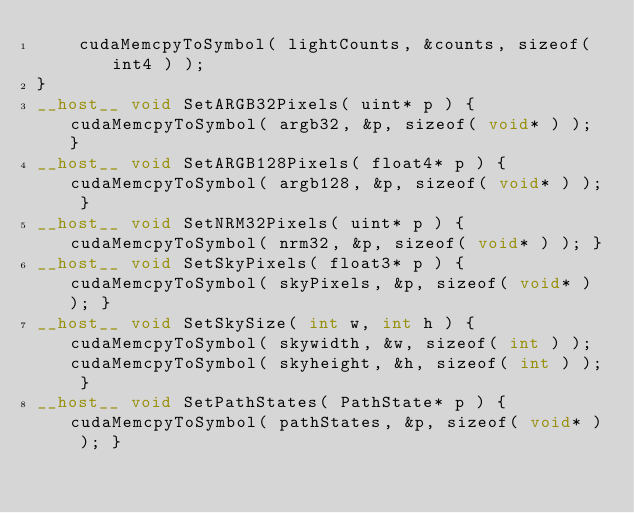Convert code to text. <code><loc_0><loc_0><loc_500><loc_500><_Cuda_>	cudaMemcpyToSymbol( lightCounts, &counts, sizeof( int4 ) );
}
__host__ void SetARGB32Pixels( uint* p ) { cudaMemcpyToSymbol( argb32, &p, sizeof( void* ) ); }
__host__ void SetARGB128Pixels( float4* p ) { cudaMemcpyToSymbol( argb128, &p, sizeof( void* ) ); }
__host__ void SetNRM32Pixels( uint* p ) { cudaMemcpyToSymbol( nrm32, &p, sizeof( void* ) ); }
__host__ void SetSkyPixels( float3* p ) { cudaMemcpyToSymbol( skyPixels, &p, sizeof( void* ) ); }
__host__ void SetSkySize( int w, int h ) { cudaMemcpyToSymbol( skywidth, &w, sizeof( int ) ); cudaMemcpyToSymbol( skyheight, &h, sizeof( int ) ); }
__host__ void SetPathStates( PathState* p ) { cudaMemcpyToSymbol( pathStates, &p, sizeof( void* ) ); }</code> 